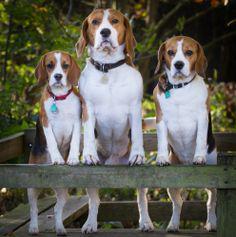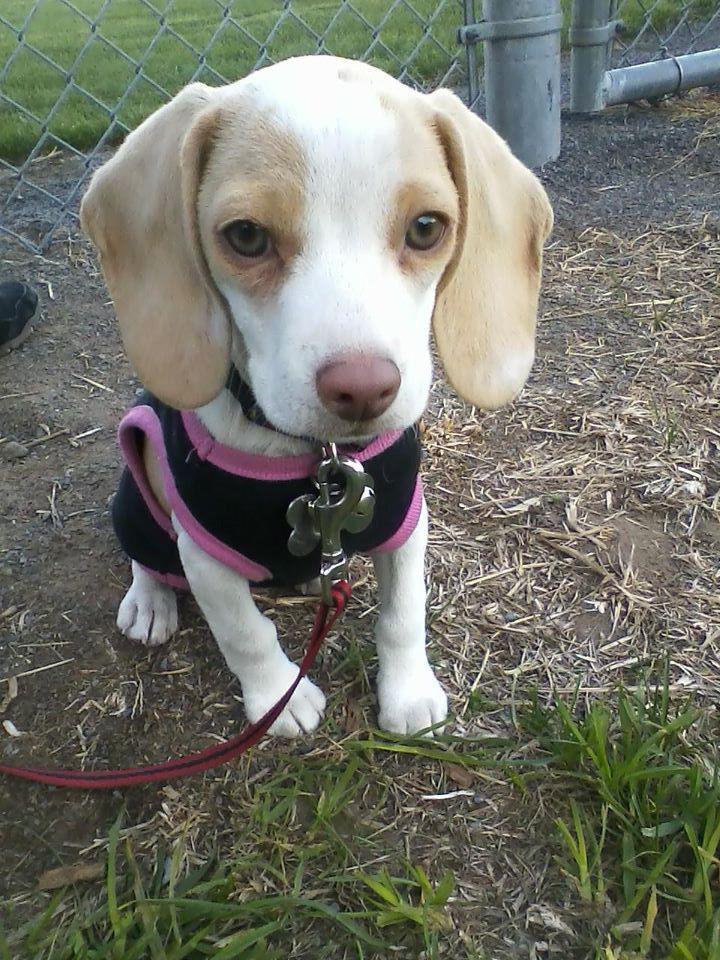The first image is the image on the left, the second image is the image on the right. For the images displayed, is the sentence "A person is behind a standing beagle, holding the base of its tail upward with one hand and propping its chin with the other." factually correct? Answer yes or no. No. The first image is the image on the left, the second image is the image on the right. Assess this claim about the two images: "A human is touching a dogs tail in the right image.". Correct or not? Answer yes or no. No. 